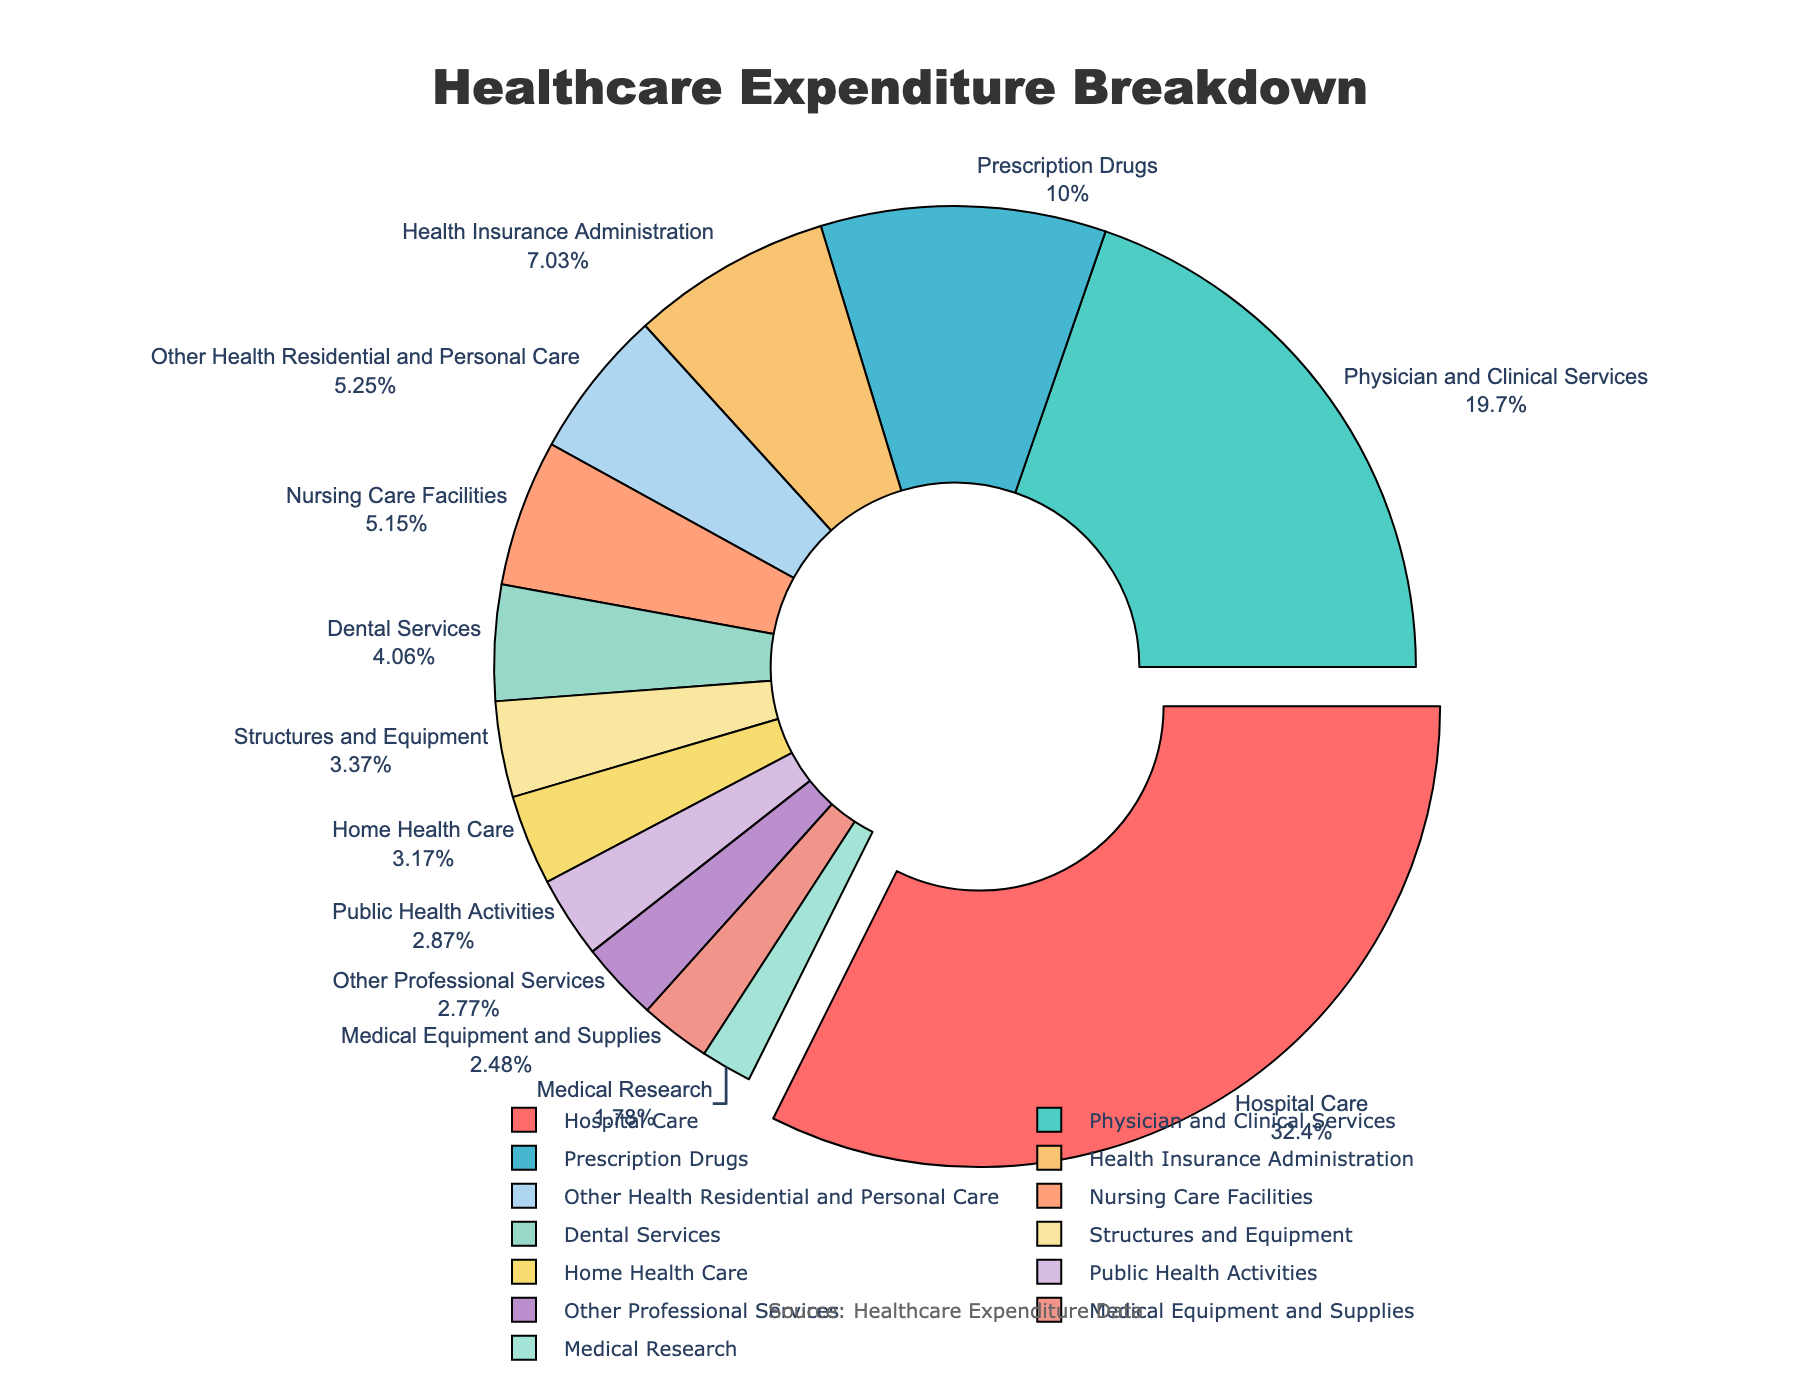How much more is spent on hospital care compared to prescription drugs? To find the difference, subtract the percentage of prescription drugs from hospital care: 32.7% - 10.1% = 22.6%.
Answer: 22.6% Which category has the smallest expenditure, and what is its percentage? Identify the category with the lowest value which is Medical Research at 1.8%.
Answer: Medical Research, 1.8% What is the combined expenditure percentage of dental services and medical equipment and supplies? Add the percentages of dental services and medical equipment and supplies: 4.1% + 2.5% = 6.6%.
Answer: 6.6% Which category stands out visually on the chart, and why? Hospital Care stands out because it is pulled out from the pie chart, indicating it has the highest expenditure.
Answer: Hospital Care What is the total percentage spent on nursing care facilities, other health residential and personal care, and home health care? Sum up the percentages for these categories: 5.2% + 5.3% + 3.2% = 13.7%.
Answer: 13.7% Are there more resources spent on physician and clinical services or on health insurance administration? Compare the two percentages: physician and clinical services (19.9%) is higher than health insurance administration (7.1%).
Answer: Physician and Clinical Services What color is used to represent public health activities? Identify the section corresponding to public health activities and note its color, which is blue.
Answer: Blue How does the expenditure on public health activities compare to that on nursing care facilities? Check the percentages: public health activities (2.9%) vs nursing care facilities (5.2%). Nursing care facilities have a higher expenditure.
Answer: Nursing Care Facilities What is the overall budget percentage for different types of professional and personal care services (other professional services and other health residential and personal care)? Sum the percentages of other professional services and other health residential and personal care: 2.8% + 5.3% = 8.1%.
Answer: 8.1% What is the difference between the expenditures on medical equipment and supplies versus structures and equipment? Subtract the percentage of structures and equipment from medical equipment and supplies: 3.4% - 2.5% = 0.9%.
Answer: 0.9% 